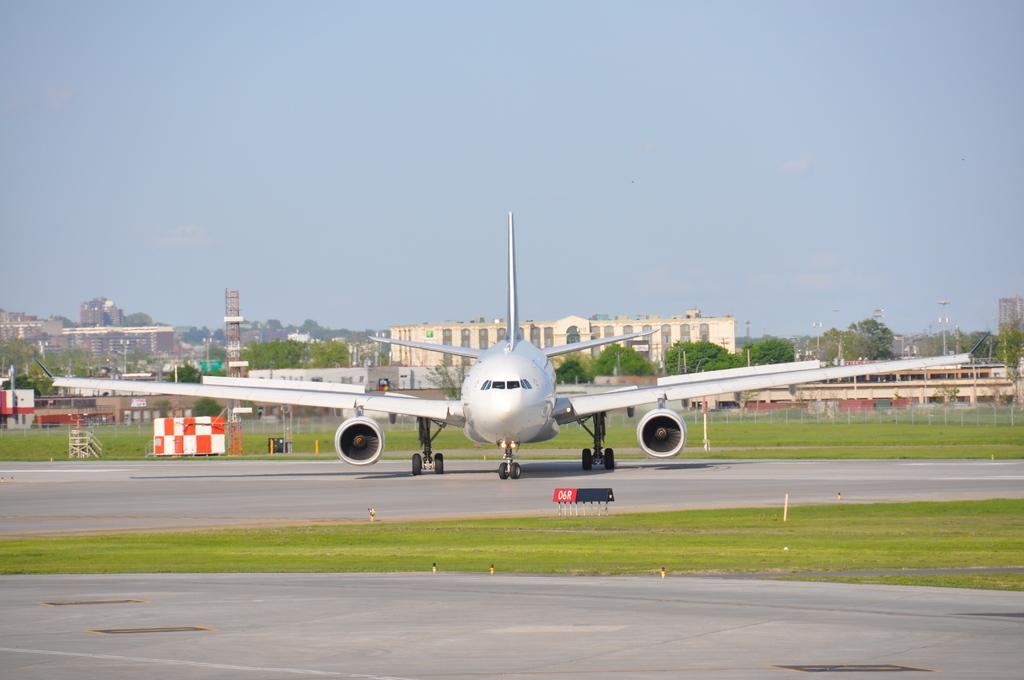What is the unusual object on the road in the image? There is an aeroplane on the road in the image. What type of vegetation can be seen in the image? There is grass visible in the image. What type of barrier is present in the image? There is a fence in the image. What type of natural structures are present in the image? There are trees in the image. What type of man-made structures are present in the image? There are buildings in the image. What type of vertical structures are present in the image? There are poles in the image. What other objects can be seen in the image? There are other objects in the image. What can be seen in the background of the image? The sky is visible in the background of the image. What type of smell can be detected from the image? There is no information about smells in the image, so it cannot be determined from the image. 